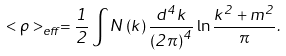Convert formula to latex. <formula><loc_0><loc_0><loc_500><loc_500>< \rho > _ { e f f } = \frac { 1 } { 2 } \int N \left ( k \right ) \frac { d ^ { 4 } k } { \left ( 2 \pi \right ) ^ { 4 } } \ln \frac { k ^ { 2 } + m ^ { 2 } } { \pi } .</formula> 